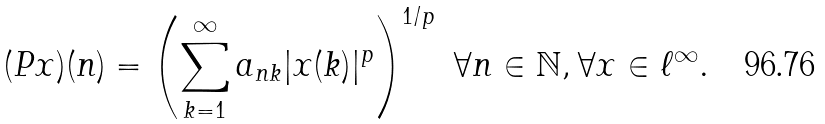<formula> <loc_0><loc_0><loc_500><loc_500>( P x ) ( n ) = \left ( \sum _ { k = 1 } ^ { \infty } a _ { n k } | x ( k ) | ^ { p } \right ) ^ { 1 / p } \ \forall n \in \mathbb { N } , \forall x \in \ell ^ { \infty } .</formula> 